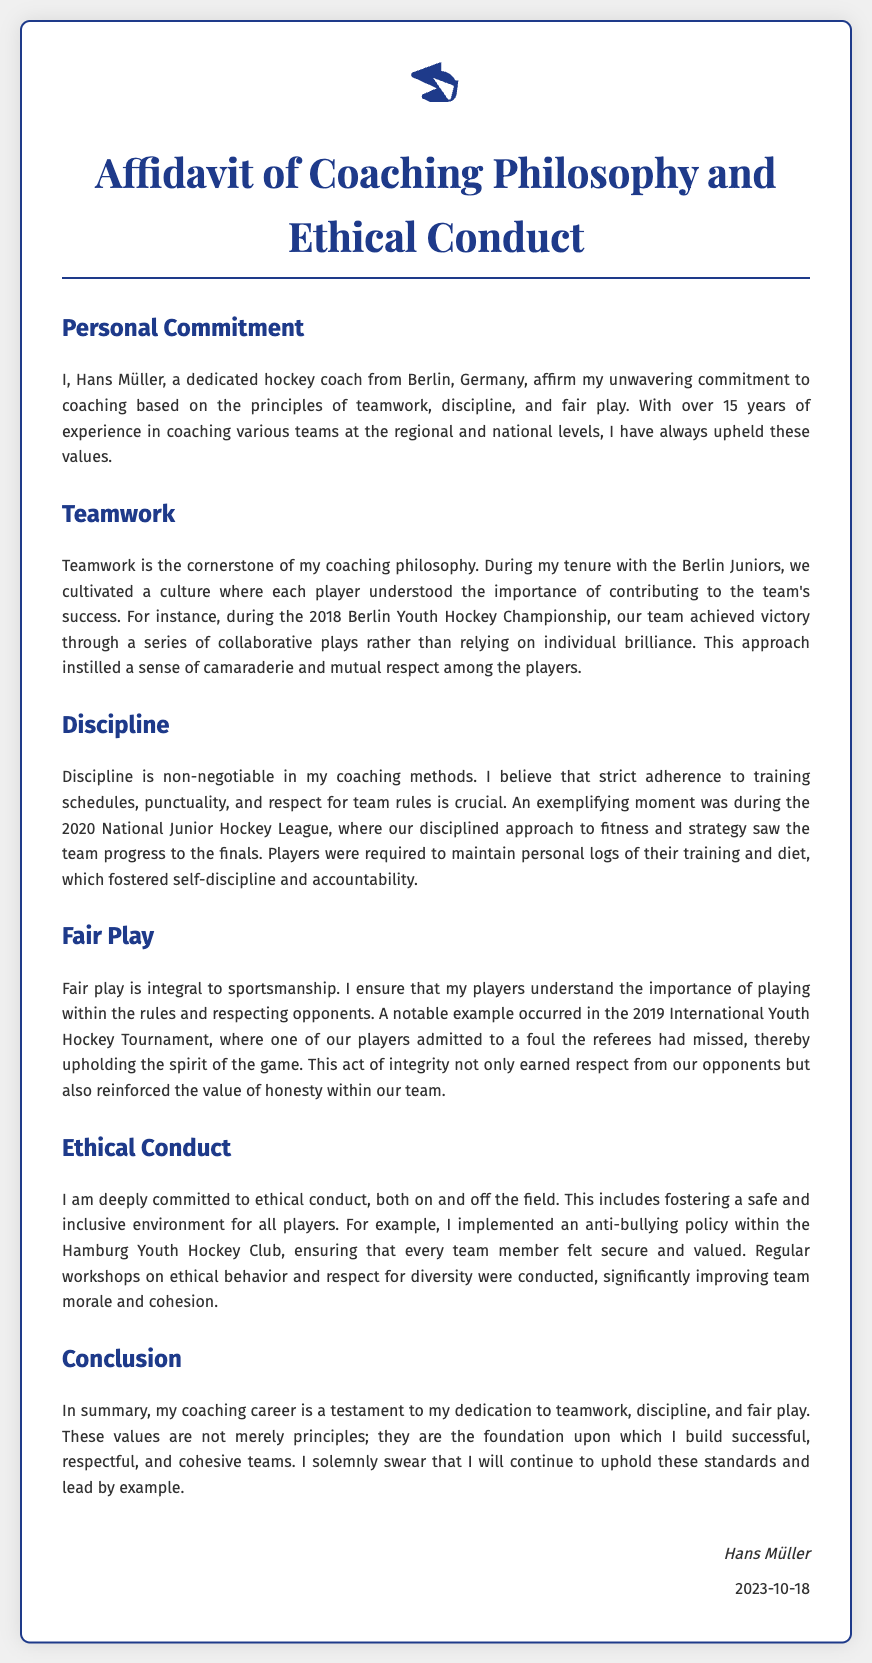What is the name of the hockey coach? The document states that the coach's name is Hans Müller.
Answer: Hans Müller How many years of coaching experience does Hans Müller have? The document mentions that Hans Müller has over 15 years of experience in coaching.
Answer: 15 years In which year did Berlin Juniors win the championship? The document specifies that the Berlin Juniors achieved victory in the 2018 Berlin Youth Hockey Championship.
Answer: 2018 What was required of players during the 2020 National Junior Hockey League? The document states that players were required to maintain personal logs of their training and diet.
Answer: Personal logs What initiative did Hans Müller implement in the Hamburg Youth Hockey Club? The document notes that he implemented an anti-bullying policy.
Answer: Anti-bullying policy What sport is central to the affidavit? The document is focused on the sport of hockey.
Answer: Hockey How does Hans Müller view discipline in coaching? The document describes discipline as non-negotiable in his coaching methods.
Answer: Non-negotiable What principle is underscored by the player's action in the 2019 International Youth Hockey Tournament? The document highlights that fair play is integral to sportsmanship.
Answer: Fair play On what date was the affidavit signed? The document specifies that the affidavit was signed on October 18, 2023.
Answer: October 18, 2023 